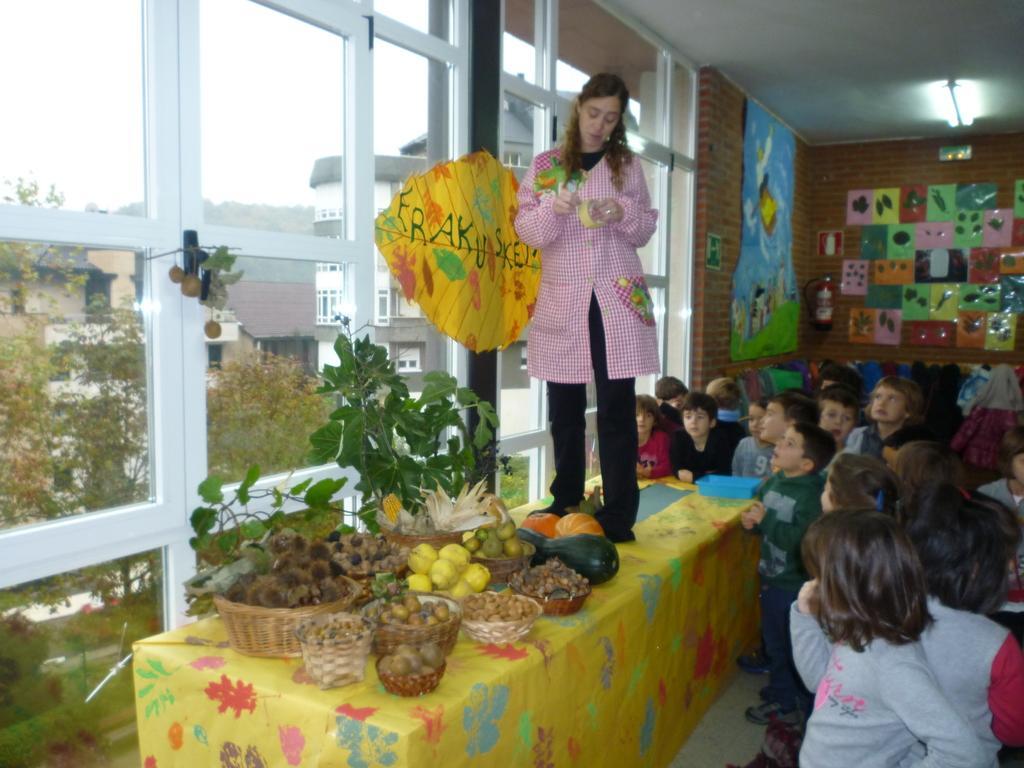Please provide a concise description of this image. Towards right we can see kids, posters, wall, fire extinguisher, light, ceiling and a object looking like cloth. In the middle of the picture we can see baskets, fruits, woman, windows, door, poster, table and plant. On the left there are buildings, trees, plants and grass. At the top left it is sky. 